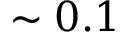<formula> <loc_0><loc_0><loc_500><loc_500>\sim 0 . 1</formula> 